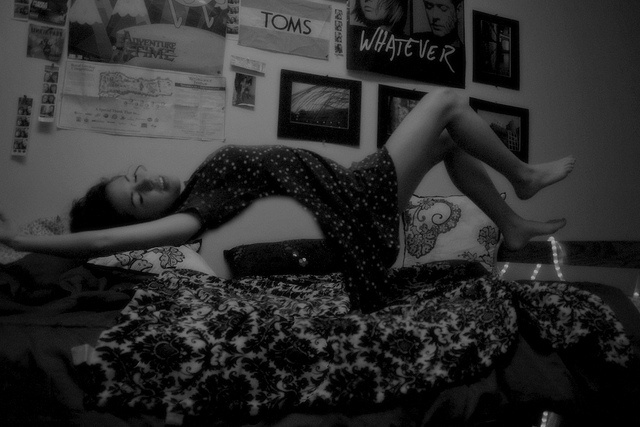Describe the objects in this image and their specific colors. I can see bed in black and gray tones and people in black and gray tones in this image. 